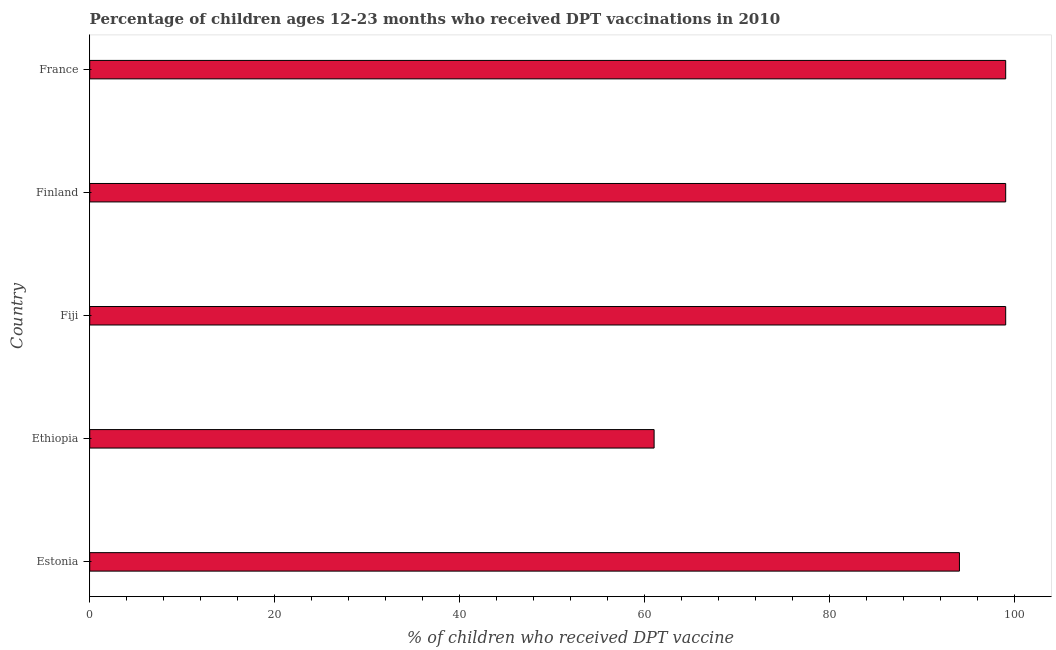What is the title of the graph?
Keep it short and to the point. Percentage of children ages 12-23 months who received DPT vaccinations in 2010. What is the label or title of the X-axis?
Make the answer very short. % of children who received DPT vaccine. What is the label or title of the Y-axis?
Ensure brevity in your answer.  Country. What is the percentage of children who received dpt vaccine in Fiji?
Provide a short and direct response. 99. Across all countries, what is the maximum percentage of children who received dpt vaccine?
Your answer should be compact. 99. In which country was the percentage of children who received dpt vaccine maximum?
Give a very brief answer. Fiji. In which country was the percentage of children who received dpt vaccine minimum?
Your answer should be compact. Ethiopia. What is the sum of the percentage of children who received dpt vaccine?
Provide a succinct answer. 452. What is the difference between the percentage of children who received dpt vaccine in Estonia and France?
Provide a short and direct response. -5. What is the average percentage of children who received dpt vaccine per country?
Keep it short and to the point. 90.4. What is the median percentage of children who received dpt vaccine?
Give a very brief answer. 99. In how many countries, is the percentage of children who received dpt vaccine greater than 24 %?
Keep it short and to the point. 5. What is the ratio of the percentage of children who received dpt vaccine in Ethiopia to that in Fiji?
Your answer should be compact. 0.62. Is the percentage of children who received dpt vaccine in Ethiopia less than that in Finland?
Your response must be concise. Yes. What is the difference between the highest and the second highest percentage of children who received dpt vaccine?
Offer a very short reply. 0. Is the sum of the percentage of children who received dpt vaccine in Ethiopia and Finland greater than the maximum percentage of children who received dpt vaccine across all countries?
Your answer should be very brief. Yes. What is the difference between the highest and the lowest percentage of children who received dpt vaccine?
Your answer should be very brief. 38. How many countries are there in the graph?
Provide a short and direct response. 5. What is the difference between two consecutive major ticks on the X-axis?
Ensure brevity in your answer.  20. Are the values on the major ticks of X-axis written in scientific E-notation?
Your answer should be compact. No. What is the % of children who received DPT vaccine of Estonia?
Offer a very short reply. 94. What is the % of children who received DPT vaccine in Fiji?
Offer a very short reply. 99. What is the % of children who received DPT vaccine of France?
Make the answer very short. 99. What is the difference between the % of children who received DPT vaccine in Estonia and Ethiopia?
Provide a short and direct response. 33. What is the difference between the % of children who received DPT vaccine in Estonia and Fiji?
Offer a very short reply. -5. What is the difference between the % of children who received DPT vaccine in Estonia and France?
Make the answer very short. -5. What is the difference between the % of children who received DPT vaccine in Ethiopia and Fiji?
Offer a very short reply. -38. What is the difference between the % of children who received DPT vaccine in Ethiopia and Finland?
Your answer should be very brief. -38. What is the difference between the % of children who received DPT vaccine in Ethiopia and France?
Give a very brief answer. -38. What is the difference between the % of children who received DPT vaccine in Fiji and Finland?
Your answer should be very brief. 0. What is the ratio of the % of children who received DPT vaccine in Estonia to that in Ethiopia?
Give a very brief answer. 1.54. What is the ratio of the % of children who received DPT vaccine in Estonia to that in Fiji?
Give a very brief answer. 0.95. What is the ratio of the % of children who received DPT vaccine in Estonia to that in Finland?
Your answer should be very brief. 0.95. What is the ratio of the % of children who received DPT vaccine in Estonia to that in France?
Ensure brevity in your answer.  0.95. What is the ratio of the % of children who received DPT vaccine in Ethiopia to that in Fiji?
Make the answer very short. 0.62. What is the ratio of the % of children who received DPT vaccine in Ethiopia to that in Finland?
Make the answer very short. 0.62. What is the ratio of the % of children who received DPT vaccine in Ethiopia to that in France?
Offer a very short reply. 0.62. What is the ratio of the % of children who received DPT vaccine in Fiji to that in France?
Your response must be concise. 1. What is the ratio of the % of children who received DPT vaccine in Finland to that in France?
Your answer should be compact. 1. 